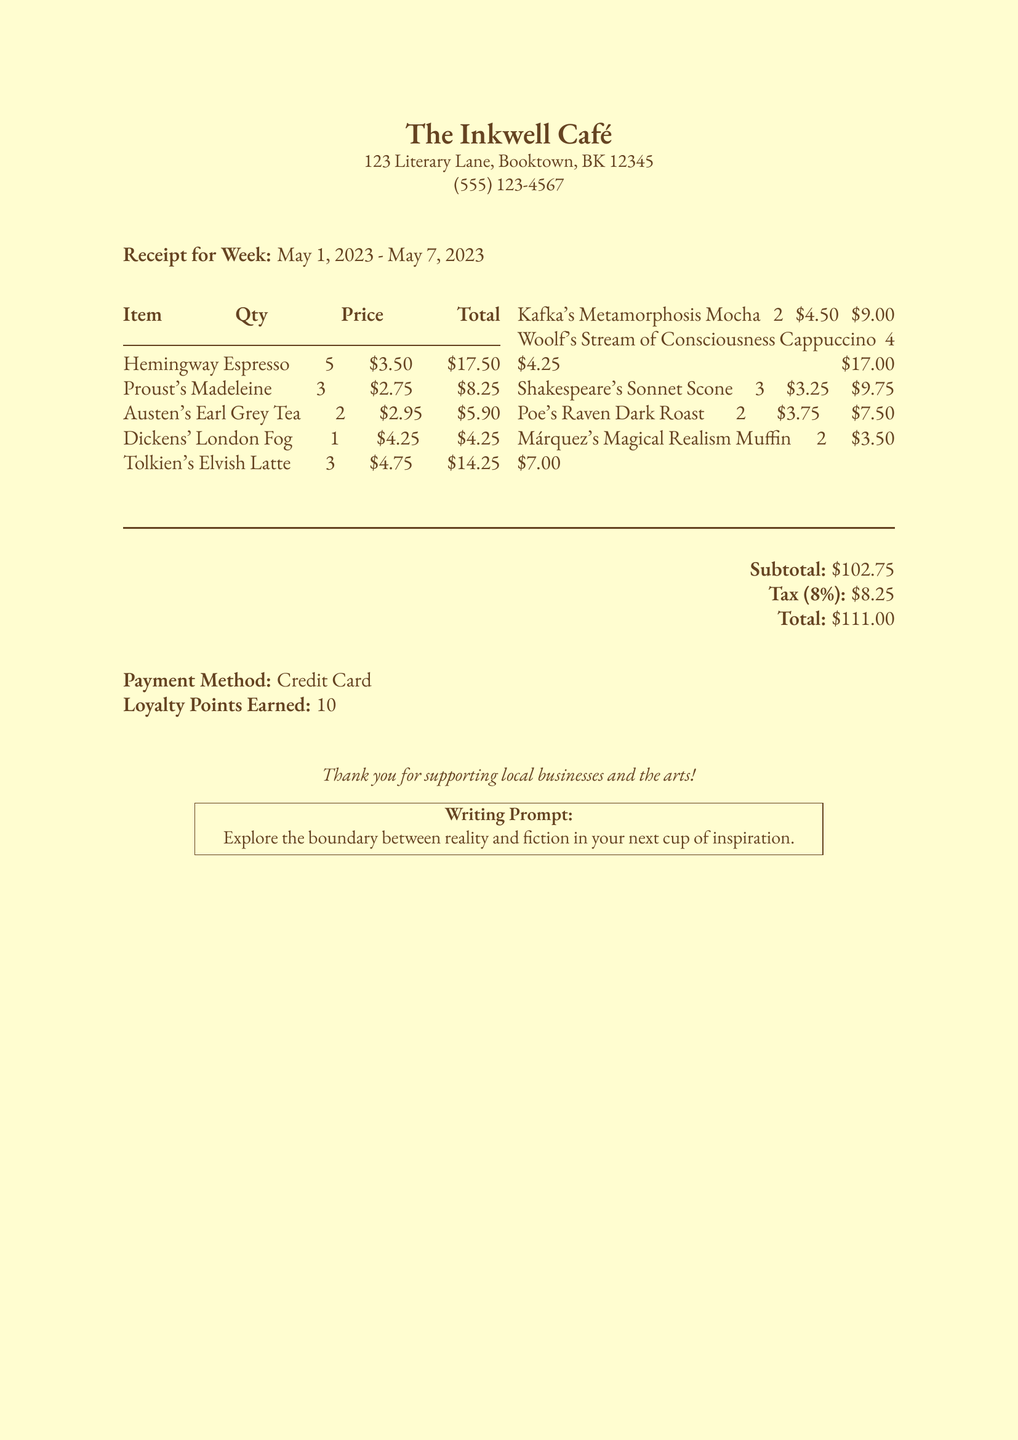What is the café name? The café name is stated clearly at the top of the receipt.
Answer: The Inkwell Café What is the address of the café? The address is provided below the café name on the receipt.
Answer: 123 Literary Lane, Booktown, BK 12345 How many Hemingway Espressos were ordered? The quantity of Hemingway Espressos is listed in the items section of the document.
Answer: 5 What is the total amount spent? The total amount is shown in the financial summary at the bottom of the receipt.
Answer: $111.00 What writing prompt is included in the receipt? The writing prompt is a special note enclosed in a box towards the end of the document.
Answer: Explore the boundary between reality and fiction in your next cup of inspiration What is the subtotal before tax? The subtotal can be found in the financial summary section right before taxes are calculated.
Answer: $102.75 How many loyalty points were earned? The loyalty points earned are explicitly mentioned in the financial summary.
Answer: 10 What was the price of Proust's Madeleine? The price is outlined in the itemized list of purchases.
Answer: $2.75 What payment method was used? The payment method is stated in the financial summary section of the receipt.
Answer: Credit Card 